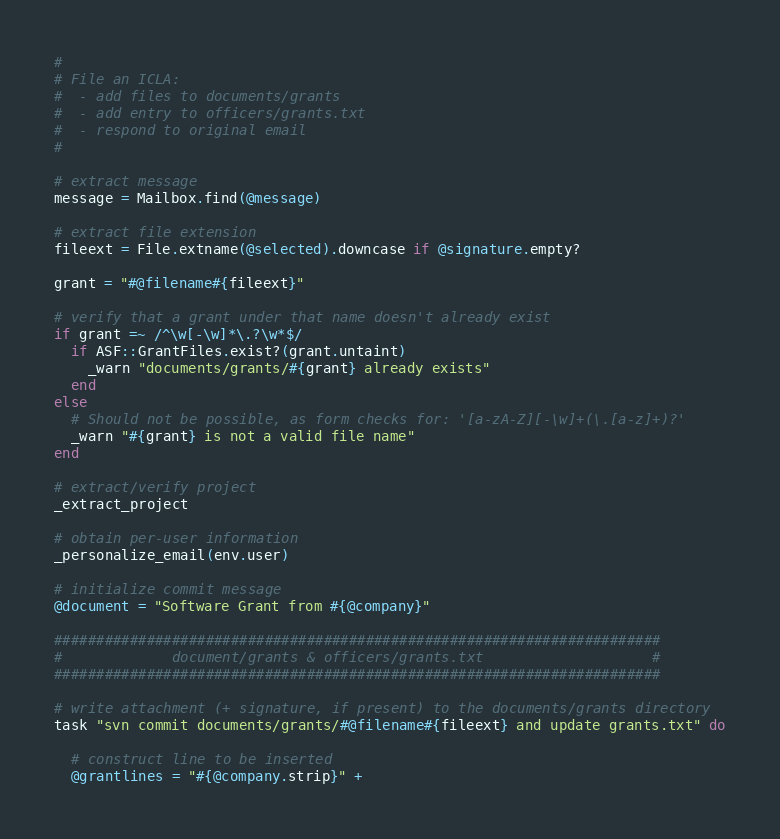<code> <loc_0><loc_0><loc_500><loc_500><_Ruby_>#
# File an ICLA:
#  - add files to documents/grants
#  - add entry to officers/grants.txt
#  - respond to original email
#

# extract message
message = Mailbox.find(@message)

# extract file extension
fileext = File.extname(@selected).downcase if @signature.empty?

grant = "#@filename#{fileext}"

# verify that a grant under that name doesn't already exist
if grant =~ /^\w[-\w]*\.?\w*$/
  if ASF::GrantFiles.exist?(grant.untaint)
    _warn "documents/grants/#{grant} already exists"
  end
else
  # Should not be possible, as form checks for: '[a-zA-Z][-\w]+(\.[a-z]+)?'
  _warn "#{grant} is not a valid file name"
end

# extract/verify project
_extract_project

# obtain per-user information
_personalize_email(env.user)

# initialize commit message
@document = "Software Grant from #{@company}"

########################################################################
#             document/grants & officers/grants.txt                    #
########################################################################

# write attachment (+ signature, if present) to the documents/grants directory
task "svn commit documents/grants/#@filename#{fileext} and update grants.txt" do

  # construct line to be inserted
  @grantlines = "#{@company.strip}" +</code> 